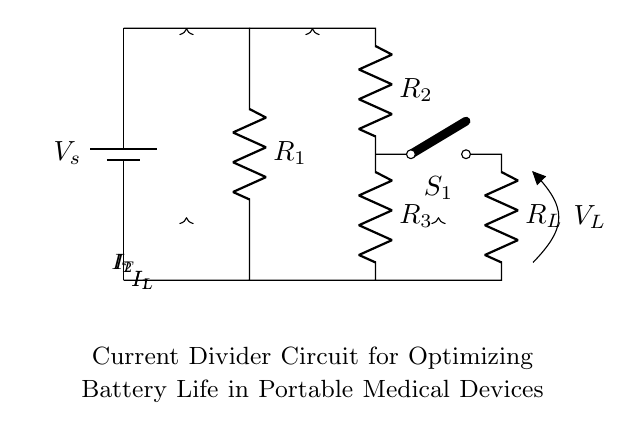What is the total current entering the circuit? The total current, labeled as I_T in the circuit, is the sum of the currents entering the two branches created by the current divider.
Answer: I_T What are the resistances in the current divider section? In the current divider section, there are two resistors labeled R_2 and R_3.
Answer: R_2, R_3 What is the role of switch S_1 in the circuit? The switch S_1 controls the flow of current to the load R_L. When the switch is closed, current can pass through R_L.
Answer: Control current How does the current divide between R_2 and R_3? The current divides between R_2 and R_3 according to Ohm's law, where the current through each resistor is inversely proportional to its resistance. Thus, I_2 and I_3 share I_T based on their resistance values.
Answer: Inversely proportional What happens to the load voltage when the load resistance R_L is increased? When R_L increases, the current I_L decreases according to Ohm's law, which may result in less voltage drop across R_L. Since V_L is directly linked to I_L, an increase in R_L generally leads to a decrease in V_L.
Answer: Decreases What ensures the optimization of battery life in the circuit? The use of the current divider configuration helps to maintain lower currents through the device when it is not needed, thus conserving battery life. By controlling how the current is split, battery drain is minimized.
Answer: Current divider 